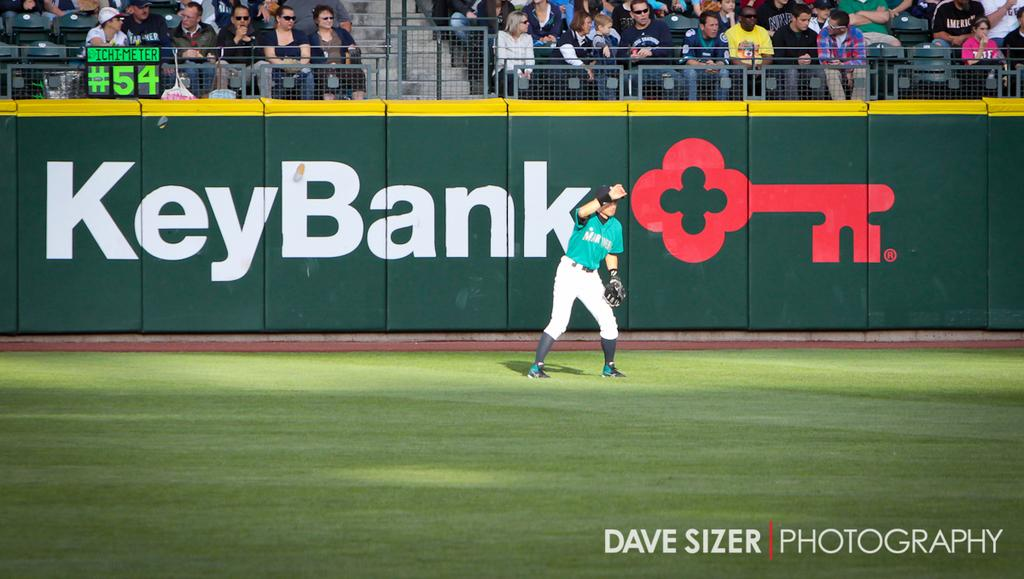<image>
Present a compact description of the photo's key features. A baseball stadium is sponsored by Key Bank during a game. 